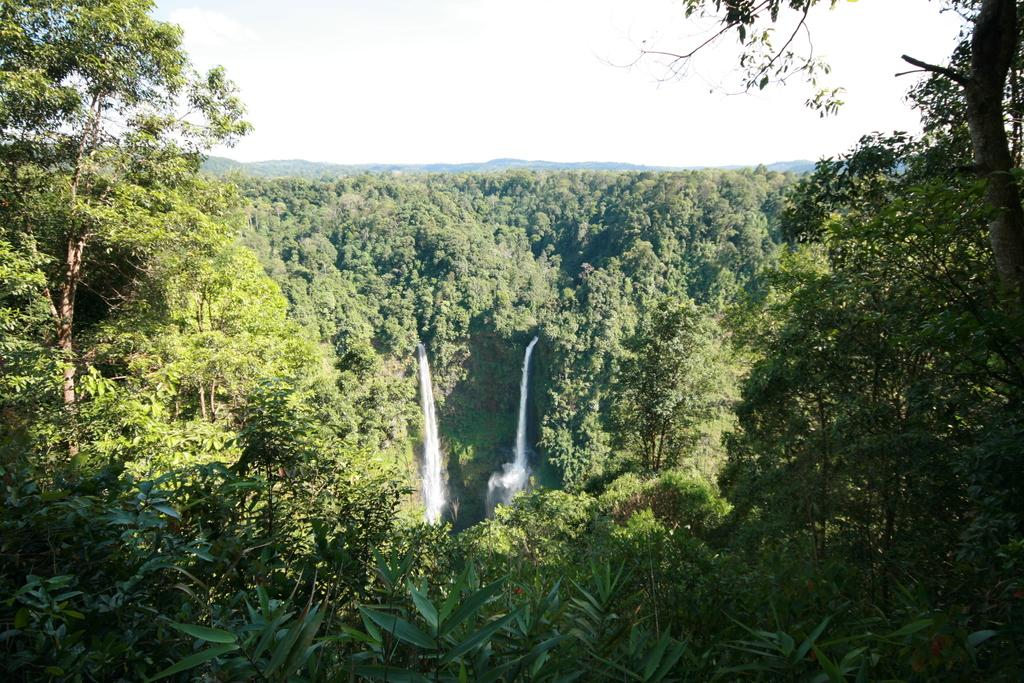What type of natural elements can be seen in the image? There are trees and a waterfall visible in the image. Where is the waterfall located in relation to the trees? The waterfall is at the center of the trees. What can be seen in the background of the image? There is a sky visible in the background of the image. How many buttons can be seen on the giants in the image? There are no giants or buttons present in the image. What type of legal advice is the lawyer providing in the image? There is no lawyer or legal advice present in the image. 